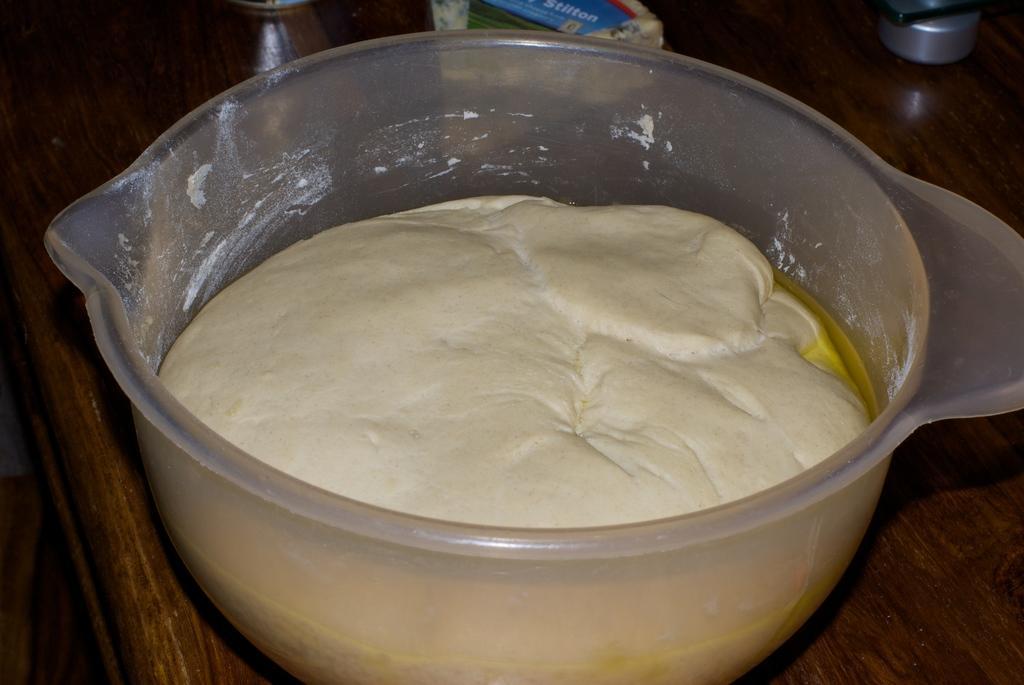Can you describe this image briefly? In this picture I can observe flour mixed with oil and water. This is placed in the white color bowl. This bowl is placed on the brown color table. 